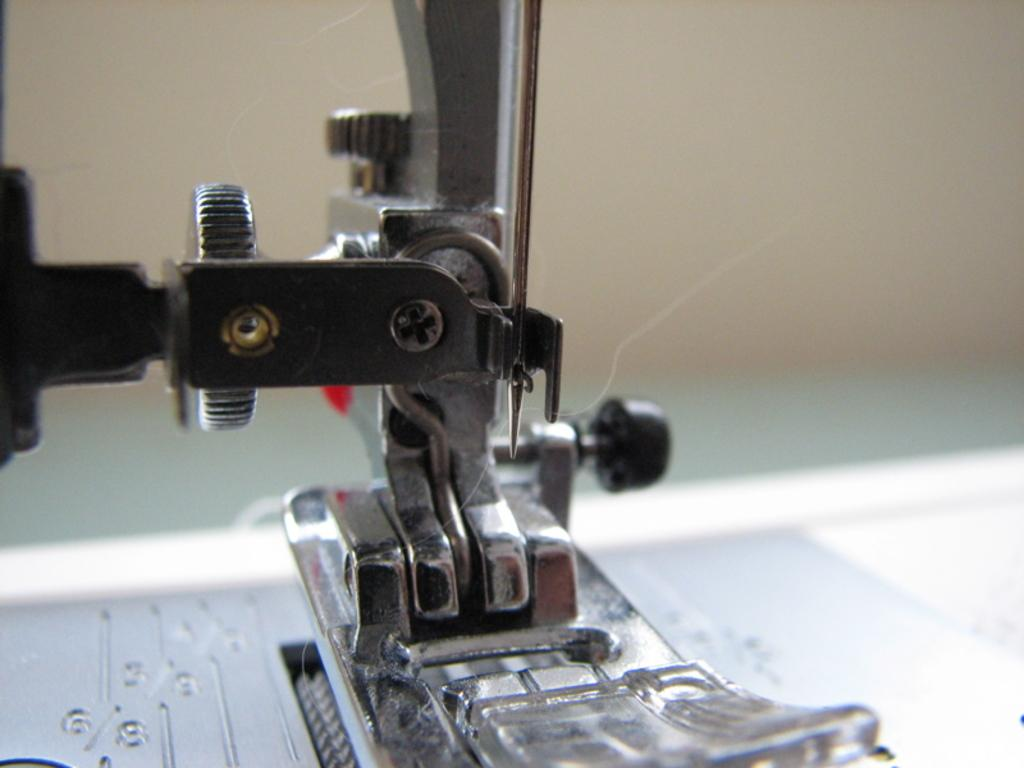What is the main object in the image? There is a sewing machine in the image. What tool is used for sewing in the image? There is a sewing needle in the image. What other small object can be seen in the image? There is a screw in the image. Can you describe the background of the image? The background of the image is blurred. How many chickens are sitting on the book in the image? There are no chickens or books present in the image. What page of the book is the sewing machine resting on in the image? There is no book or page in the image; it only features a sewing machine, a sewing needle, and a screw. 